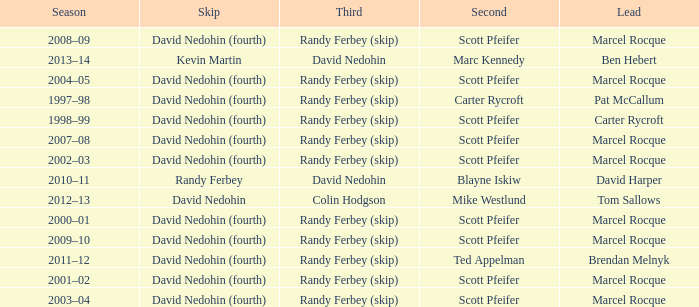Which Skip has a Season of 2002–03? David Nedohin (fourth). 